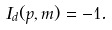<formula> <loc_0><loc_0><loc_500><loc_500>I _ { d } ( p , m ) = - 1 .</formula> 